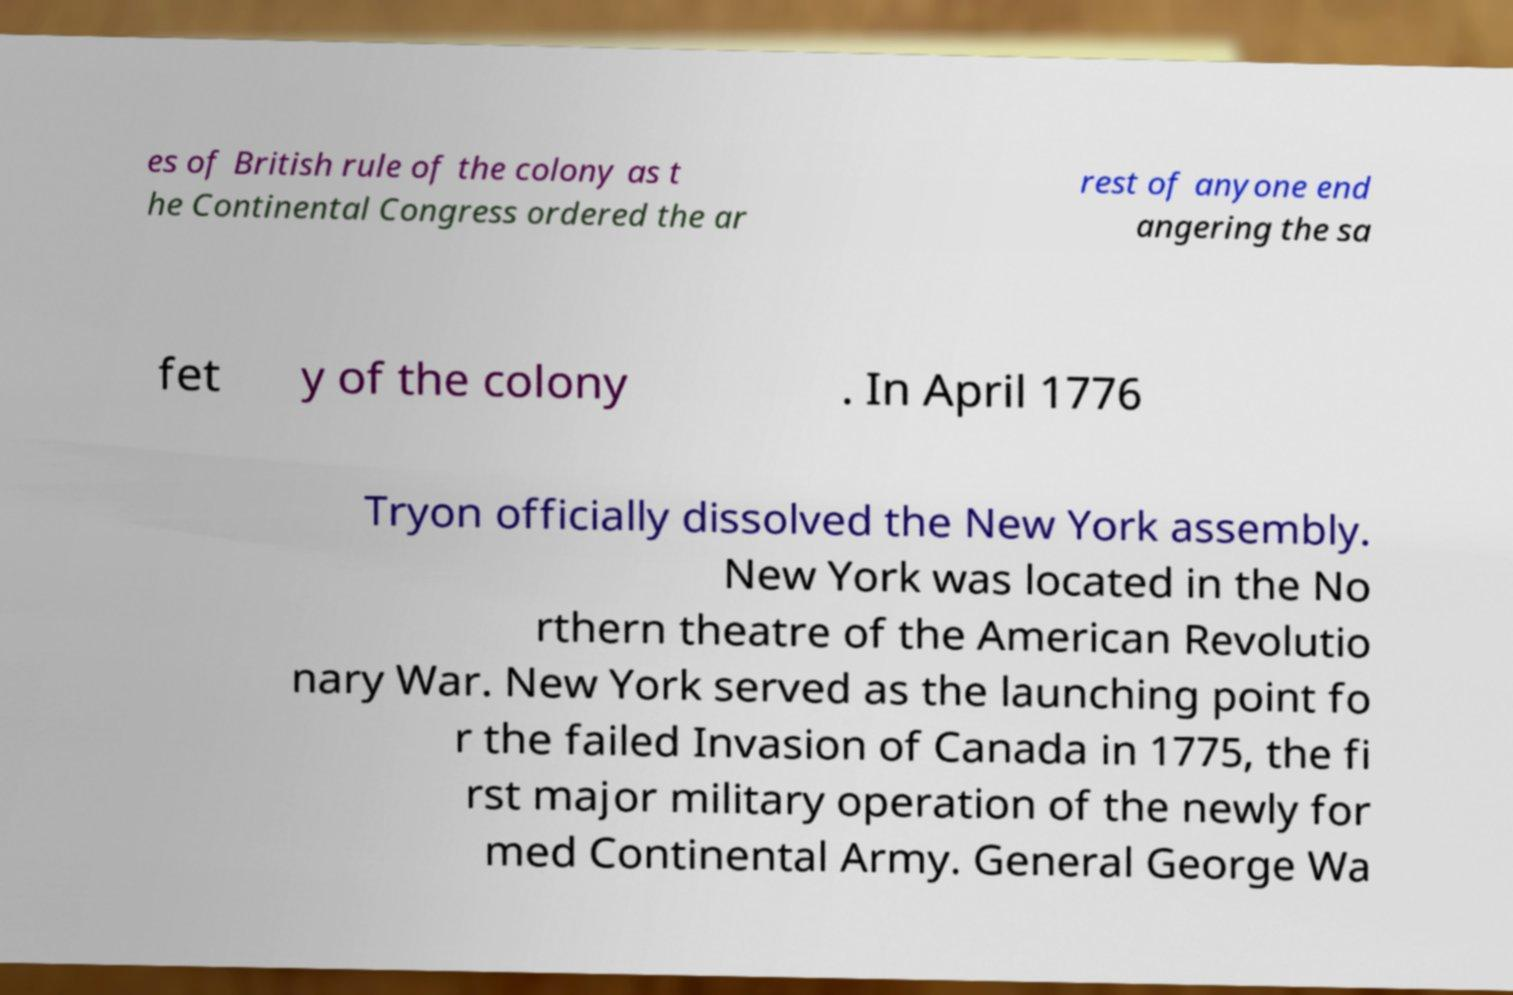What messages or text are displayed in this image? I need them in a readable, typed format. es of British rule of the colony as t he Continental Congress ordered the ar rest of anyone end angering the sa fet y of the colony . In April 1776 Tryon officially dissolved the New York assembly. New York was located in the No rthern theatre of the American Revolutio nary War. New York served as the launching point fo r the failed Invasion of Canada in 1775, the fi rst major military operation of the newly for med Continental Army. General George Wa 